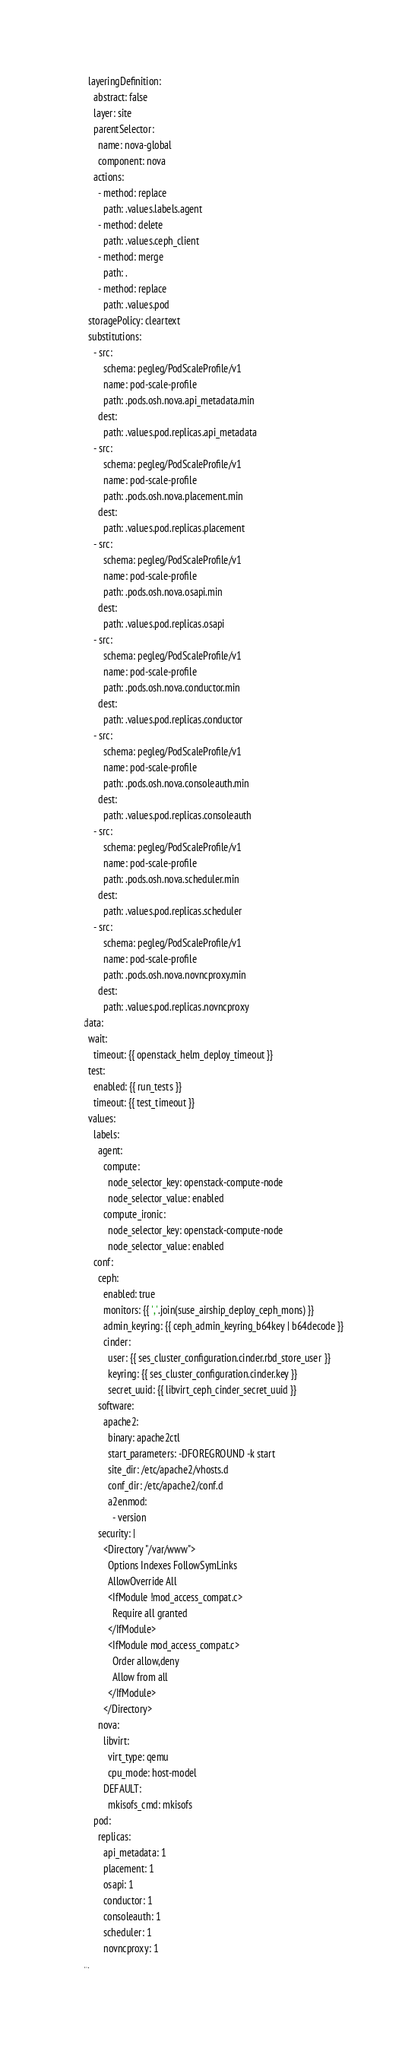<code> <loc_0><loc_0><loc_500><loc_500><_YAML_>  layeringDefinition:
    abstract: false
    layer: site
    parentSelector:
      name: nova-global
      component: nova
    actions:
      - method: replace
        path: .values.labels.agent
      - method: delete
        path: .values.ceph_client
      - method: merge
        path: .
      - method: replace
        path: .values.pod
  storagePolicy: cleartext
  substitutions:
    - src:
        schema: pegleg/PodScaleProfile/v1
        name: pod-scale-profile
        path: .pods.osh.nova.api_metadata.min
      dest:
        path: .values.pod.replicas.api_metadata
    - src:
        schema: pegleg/PodScaleProfile/v1
        name: pod-scale-profile
        path: .pods.osh.nova.placement.min
      dest:
        path: .values.pod.replicas.placement
    - src:
        schema: pegleg/PodScaleProfile/v1
        name: pod-scale-profile
        path: .pods.osh.nova.osapi.min
      dest:
        path: .values.pod.replicas.osapi
    - src:
        schema: pegleg/PodScaleProfile/v1
        name: pod-scale-profile
        path: .pods.osh.nova.conductor.min
      dest:
        path: .values.pod.replicas.conductor
    - src:
        schema: pegleg/PodScaleProfile/v1
        name: pod-scale-profile
        path: .pods.osh.nova.consoleauth.min
      dest:
        path: .values.pod.replicas.consoleauth
    - src:
        schema: pegleg/PodScaleProfile/v1
        name: pod-scale-profile
        path: .pods.osh.nova.scheduler.min
      dest:
        path: .values.pod.replicas.scheduler
    - src:
        schema: pegleg/PodScaleProfile/v1
        name: pod-scale-profile
        path: .pods.osh.nova.novncproxy.min
      dest:
        path: .values.pod.replicas.novncproxy
data:
  wait:
    timeout: {{ openstack_helm_deploy_timeout }}
  test:
    enabled: {{ run_tests }}
    timeout: {{ test_timeout }}
  values:
    labels:
      agent:
        compute:
          node_selector_key: openstack-compute-node
          node_selector_value: enabled
        compute_ironic:
          node_selector_key: openstack-compute-node
          node_selector_value: enabled
    conf:
      ceph:
        enabled: true
        monitors: {{ ','.join(suse_airship_deploy_ceph_mons) }}
        admin_keyring: {{ ceph_admin_keyring_b64key | b64decode }}
        cinder:
          user: {{ ses_cluster_configuration.cinder.rbd_store_user }}
          keyring: {{ ses_cluster_configuration.cinder.key }}
          secret_uuid: {{ libvirt_ceph_cinder_secret_uuid }}
      software:
        apache2:
          binary: apache2ctl
          start_parameters: -DFOREGROUND -k start
          site_dir: /etc/apache2/vhosts.d
          conf_dir: /etc/apache2/conf.d
          a2enmod:
            - version
      security: |
        <Directory "/var/www">
          Options Indexes FollowSymLinks
          AllowOverride All
          <IfModule !mod_access_compat.c>
            Require all granted
          </IfModule>
          <IfModule mod_access_compat.c>
            Order allow,deny
            Allow from all
          </IfModule>
        </Directory>
      nova:
        libvirt:
          virt_type: qemu
          cpu_mode: host-model
        DEFAULT:
          mkisofs_cmd: mkisofs
    pod:
      replicas:
        api_metadata: 1 
        placement: 1
        osapi: 1
        conductor: 1
        consoleauth: 1
        scheduler: 1
        novncproxy: 1
...
</code> 